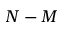<formula> <loc_0><loc_0><loc_500><loc_500>N - M</formula> 